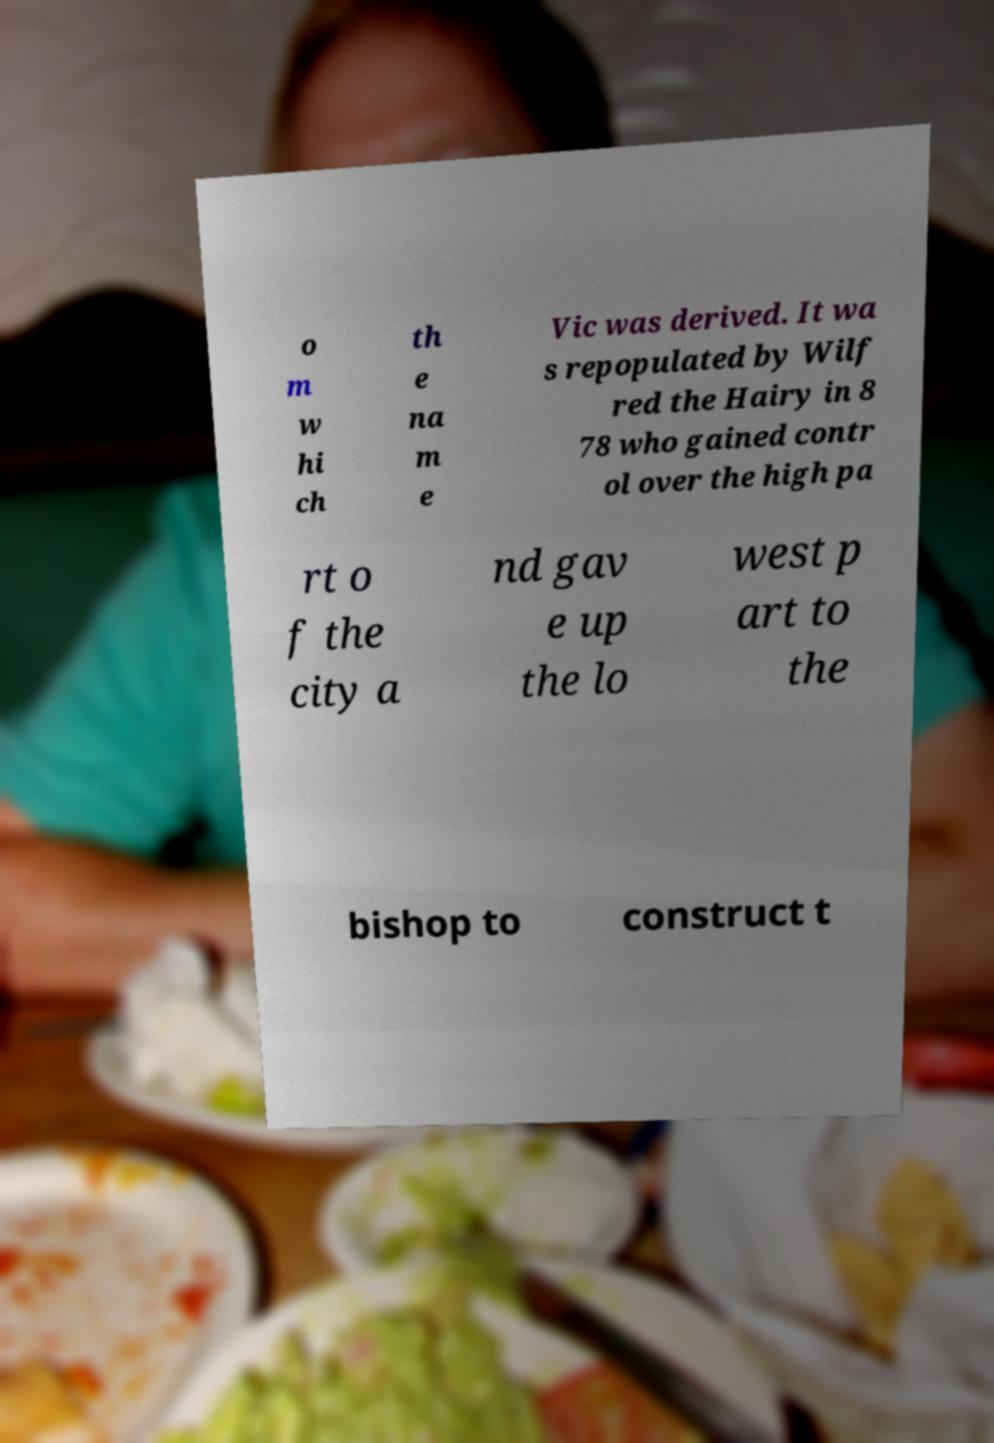For documentation purposes, I need the text within this image transcribed. Could you provide that? o m w hi ch th e na m e Vic was derived. It wa s repopulated by Wilf red the Hairy in 8 78 who gained contr ol over the high pa rt o f the city a nd gav e up the lo west p art to the bishop to construct t 